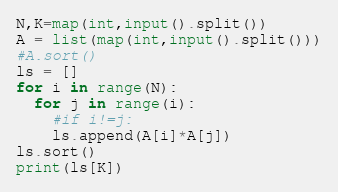<code> <loc_0><loc_0><loc_500><loc_500><_Python_>N,K=map(int,input().split())
A = list(map(int,input().split()))
#A.sort()
ls = []
for i in range(N):
  for j in range(i):
    #if i!=j:
    ls.append(A[i]*A[j])
ls.sort()
print(ls[K])
</code> 